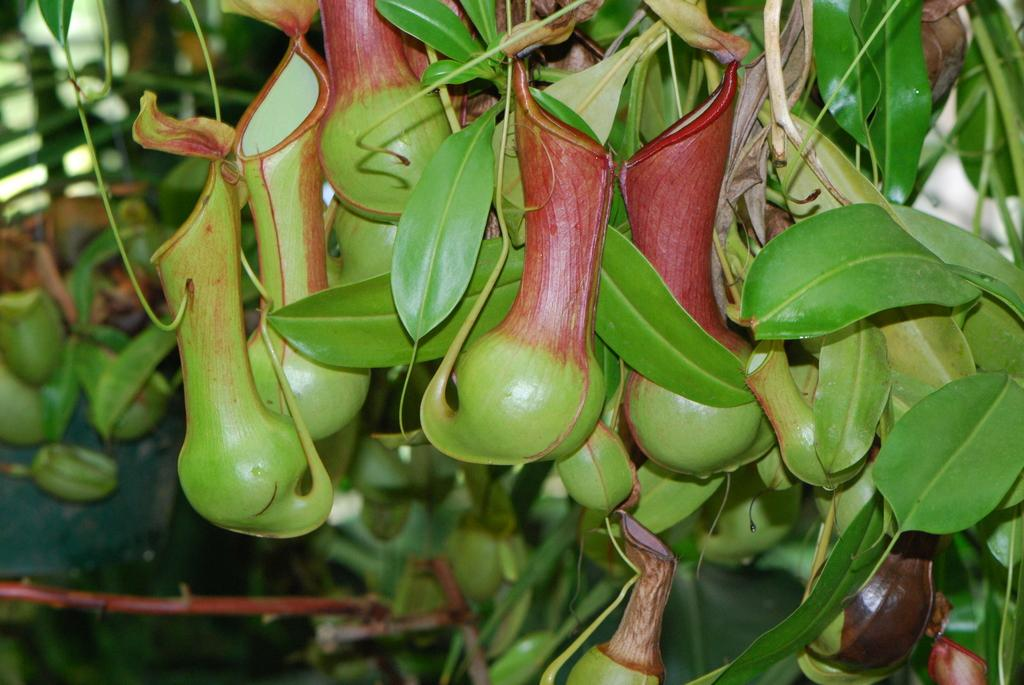What type of natural elements can be seen in the image? There are leaves in the image. What else can be seen in the image besides the leaves? There are objects and stems in the image. What is the name of the person holding the tongue in the image? There is: There is no person or tongue present in the image; it only contains leaves, objects, and stems. 